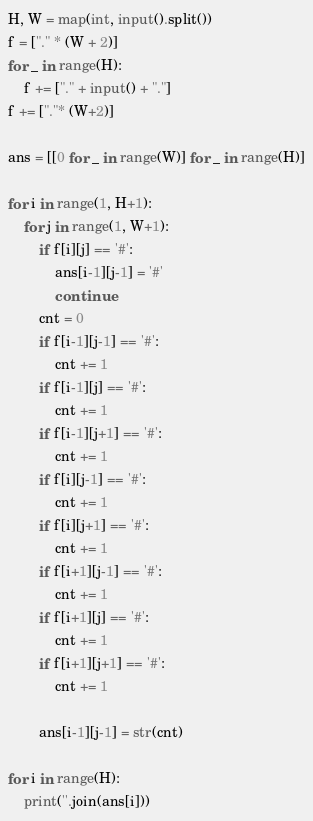<code> <loc_0><loc_0><loc_500><loc_500><_Python_>H, W = map(int, input().split())
f = ["." * (W + 2)]
for _ in range(H):
    f += ["." + input() + "."]
f += ["."* (W+2)]

ans = [[0 for _ in range(W)] for _ in range(H)]

for i in range(1, H+1):
    for j in range(1, W+1):
        if f[i][j] == '#':
            ans[i-1][j-1] = '#'
            continue
        cnt = 0
        if f[i-1][j-1] == '#':
            cnt += 1
        if f[i-1][j] == '#':
            cnt += 1
        if f[i-1][j+1] == '#':
            cnt += 1
        if f[i][j-1] == '#':
            cnt += 1
        if f[i][j+1] == '#':
            cnt += 1
        if f[i+1][j-1] == '#':
            cnt += 1
        if f[i+1][j] == '#':
            cnt += 1
        if f[i+1][j+1] == '#':
            cnt += 1
            
        ans[i-1][j-1] = str(cnt)
        
for i in range(H):
    print(''.join(ans[i]))</code> 